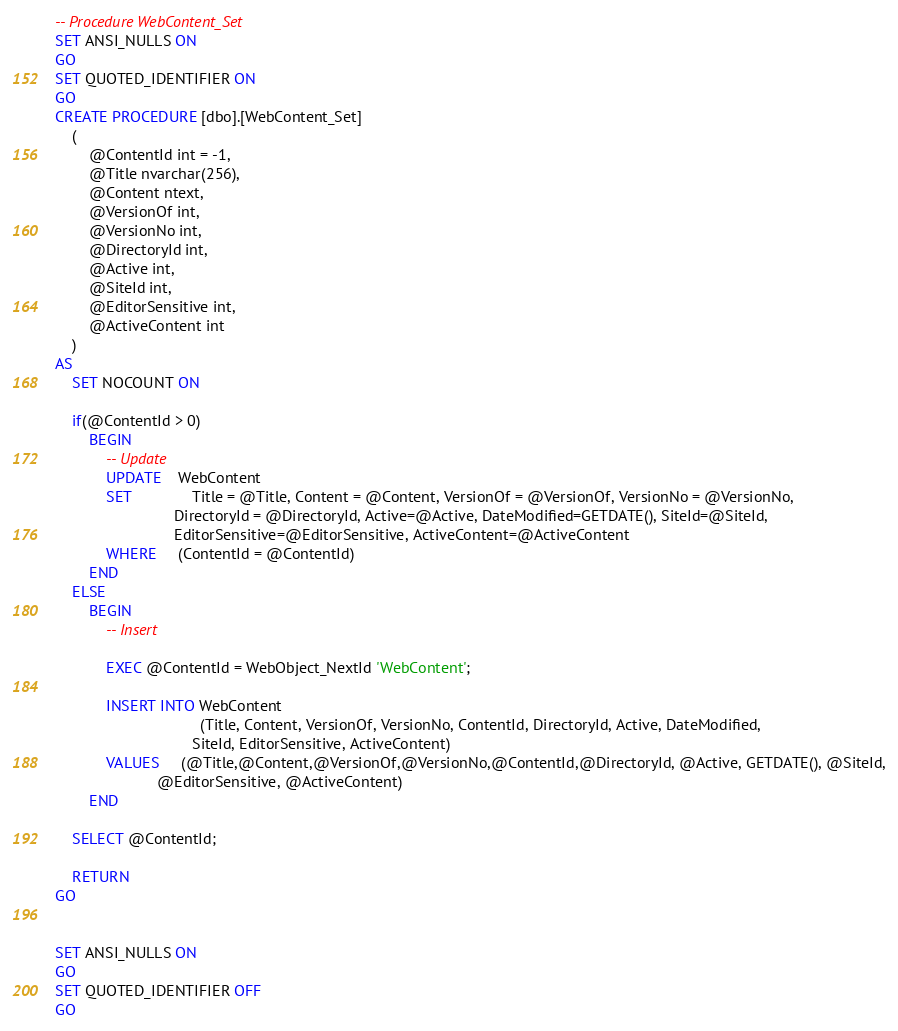<code> <loc_0><loc_0><loc_500><loc_500><_SQL_>
-- Procedure WebContent_Set
SET ANSI_NULLS ON
GO
SET QUOTED_IDENTIFIER ON
GO
CREATE PROCEDURE [dbo].[WebContent_Set]
	(
		@ContentId int = -1,
		@Title nvarchar(256),
		@Content ntext,
		@VersionOf int,
		@VersionNo int,
		@DirectoryId int,
		@Active int,
		@SiteId int,
		@EditorSensitive int,
		@ActiveContent int
	)
AS
	SET NOCOUNT ON
	
	if(@ContentId > 0)
		BEGIN
			-- Update
			UPDATE    WebContent
			SET              Title = @Title, Content = @Content, VersionOf = @VersionOf, VersionNo = @VersionNo,
							DirectoryId = @DirectoryId, Active=@Active, DateModified=GETDATE(), SiteId=@SiteId,
							EditorSensitive=@EditorSensitive, ActiveContent=@ActiveContent
			WHERE     (ContentId = @ContentId)
		END
	ELSE
		BEGIN
			-- Insert

			EXEC @ContentId = WebObject_NextId 'WebContent';
			
			INSERT INTO WebContent
			                      (Title, Content, VersionOf, VersionNo, ContentId, DirectoryId, Active, DateModified,
								SiteId, EditorSensitive, ActiveContent)
			VALUES     (@Title,@Content,@VersionOf,@VersionNo,@ContentId,@DirectoryId, @Active, GETDATE(), @SiteId,
						@EditorSensitive, @ActiveContent)
		END
	
	SELECT @ContentId;
	
	RETURN
GO


SET ANSI_NULLS ON
GO
SET QUOTED_IDENTIFIER OFF
GO

</code> 